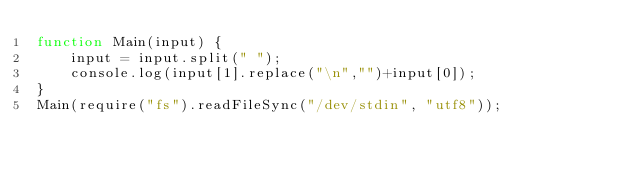Convert code to text. <code><loc_0><loc_0><loc_500><loc_500><_JavaScript_>function Main(input) {
    input = input.split(" ");
    console.log(input[1].replace("\n","")+input[0]);
}
Main(require("fs").readFileSync("/dev/stdin", "utf8"));
</code> 